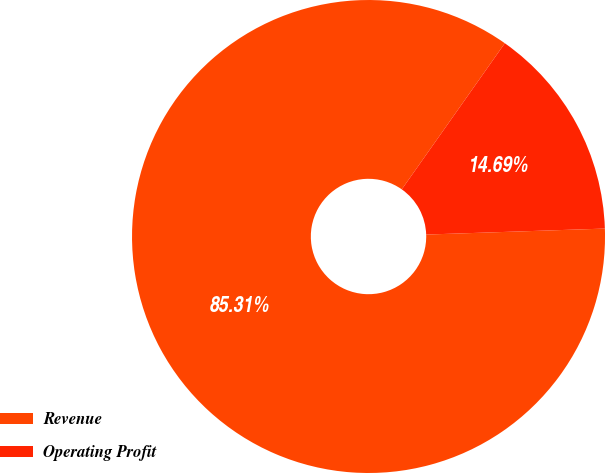Convert chart to OTSL. <chart><loc_0><loc_0><loc_500><loc_500><pie_chart><fcel>Revenue<fcel>Operating Profit<nl><fcel>85.31%<fcel>14.69%<nl></chart> 